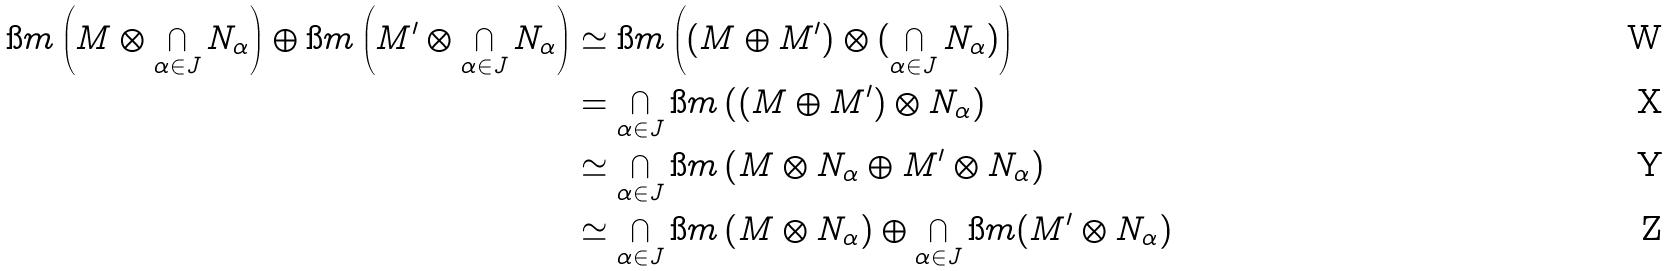Convert formula to latex. <formula><loc_0><loc_0><loc_500><loc_500>\i m \left ( M \otimes \bigcap _ { \alpha \in J } N _ { \alpha } \right ) \oplus \i m \left ( M ^ { \prime } \otimes \bigcap _ { \alpha \in J } N _ { \alpha } \right ) & \simeq \i m \left ( ( M \oplus M ^ { \prime } ) \otimes ( \bigcap _ { \alpha \in J } N _ { \alpha } ) \right ) \\ & = \bigcap _ { \alpha \in J } \i m \left ( ( M \oplus M ^ { \prime } ) \otimes N _ { \alpha } \right ) \\ & \simeq \bigcap _ { \alpha \in J } \i m \left ( M \otimes N _ { \alpha } \oplus M ^ { \prime } \otimes N _ { \alpha } \right ) \\ & \simeq \bigcap _ { \alpha \in J } \i m \left ( M \otimes N _ { \alpha } \right ) \oplus \bigcap _ { \alpha \in J } \i m ( M ^ { \prime } \otimes N _ { \alpha } )</formula> 